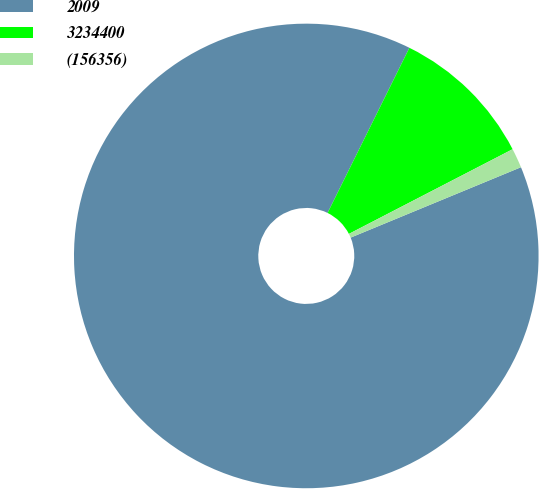Convert chart. <chart><loc_0><loc_0><loc_500><loc_500><pie_chart><fcel>2009<fcel>3234400<fcel>(156356)<nl><fcel>88.56%<fcel>10.08%<fcel>1.36%<nl></chart> 